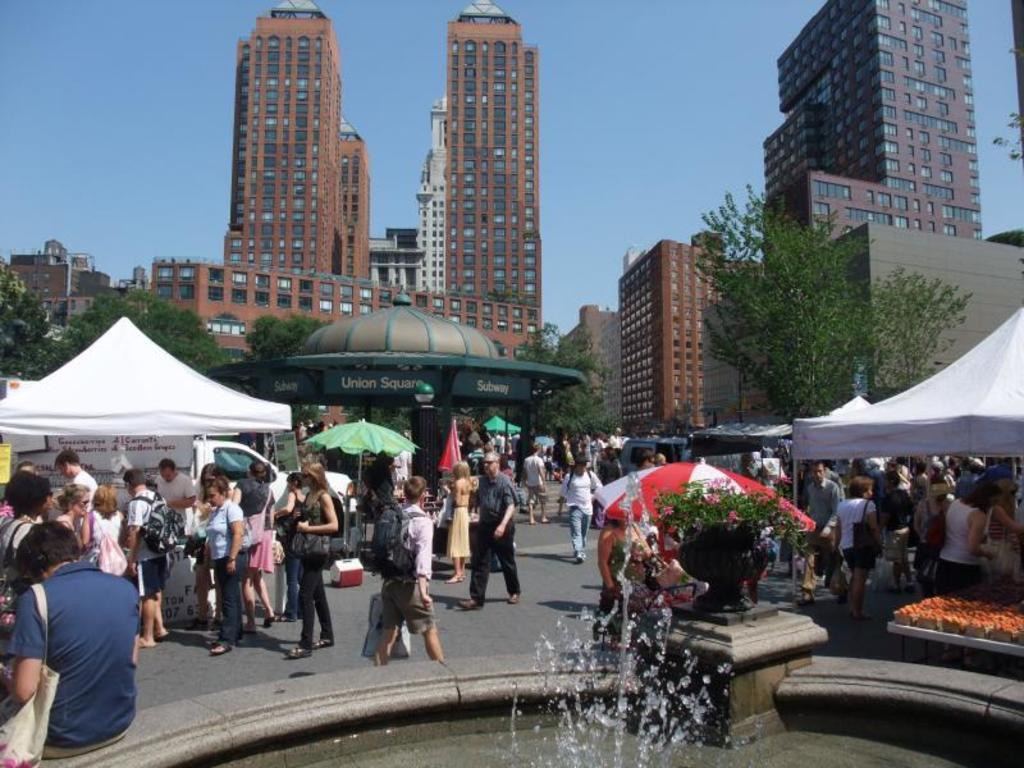What type of structures can be seen in the image? There are buildings in the image. What other natural elements are present in the image? There are trees in the image. Are there any temporary shelters visible in the image? Yes, there are tents in the image. Can you describe the people in the image? There are people at the bottom of the image. What is a notable feature in the image? There is a fountain in the image. What can be seen in the background of the image? The sky is visible in the background of the image, and there is a car in the background as well. What type of unit is being measured by the judge in the image? There is no judge or measurement unit present in the image. What type of oil can be seen dripping from the car in the image? There is no oil or dripping substance visible on the car in the image. 